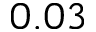Convert formula to latex. <formula><loc_0><loc_0><loc_500><loc_500>0 . 0 3</formula> 